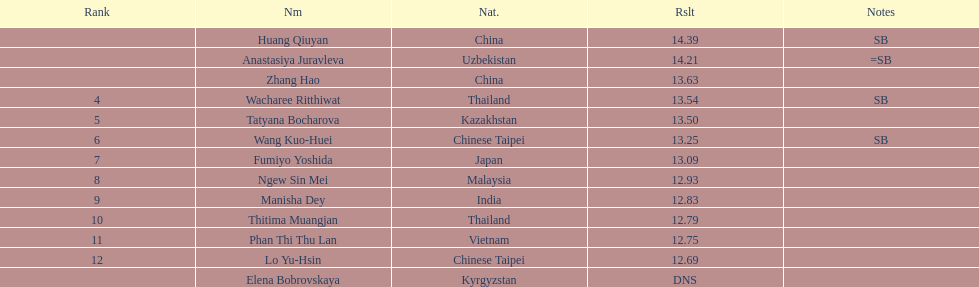What nationality was the woman who won first place? China. 